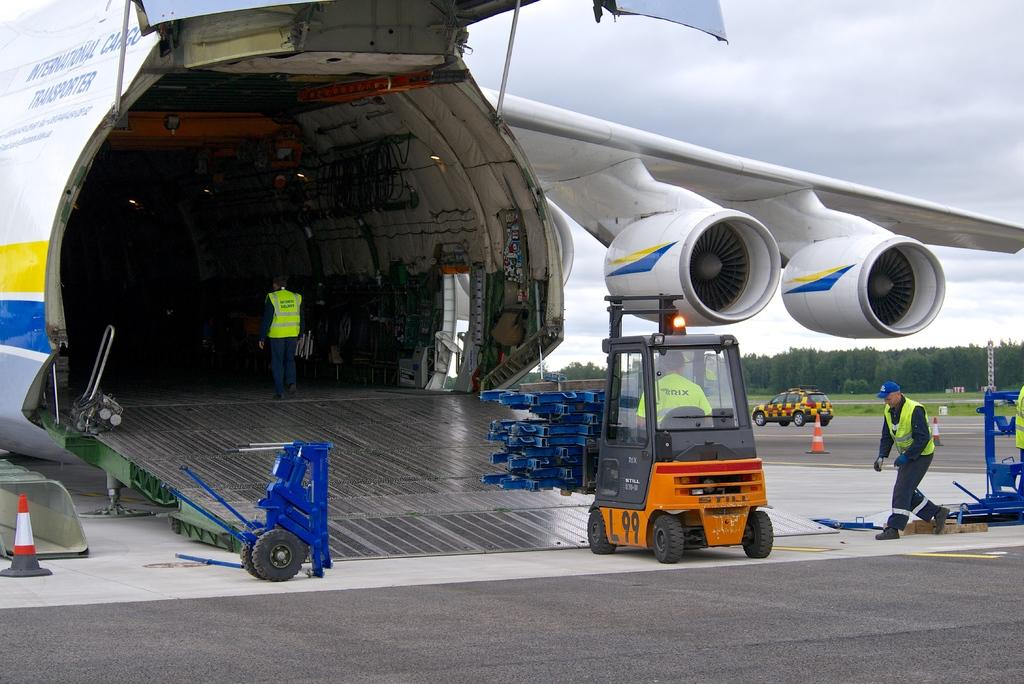Provide a one-sentence caption for the provided image. A forklift is driving into the rear of a large International Cargo Transporter. 